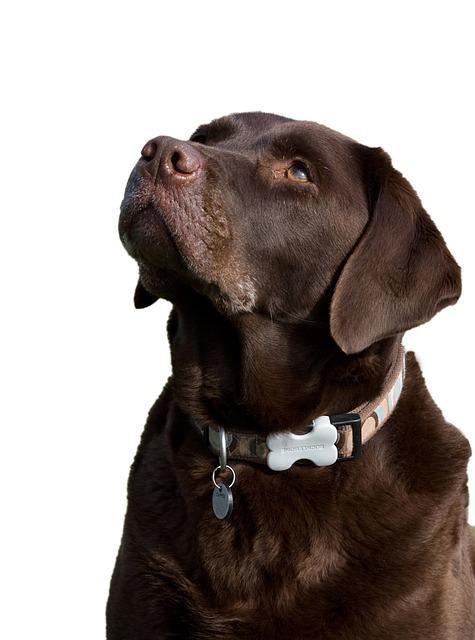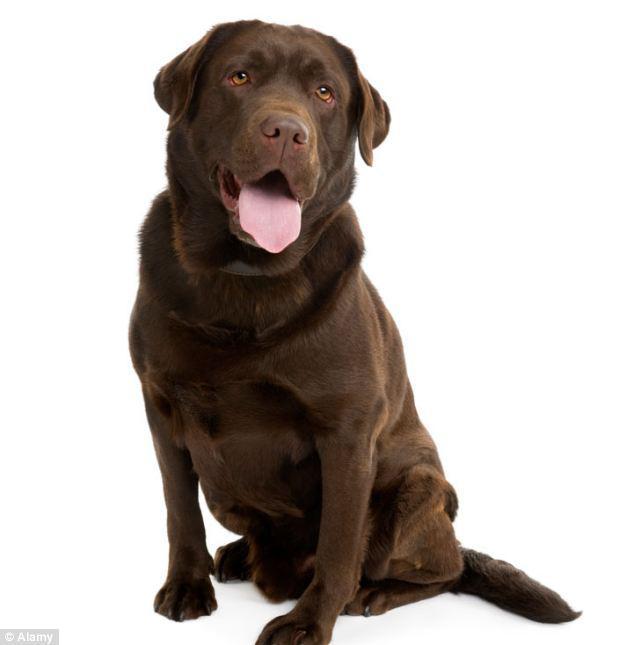The first image is the image on the left, the second image is the image on the right. Given the left and right images, does the statement "none of the dogs in the image pair have collars on" hold true? Answer yes or no. No. The first image is the image on the left, the second image is the image on the right. Assess this claim about the two images: "Two dogs are sitting and two dogs are lying down.". Correct or not? Answer yes or no. No. 